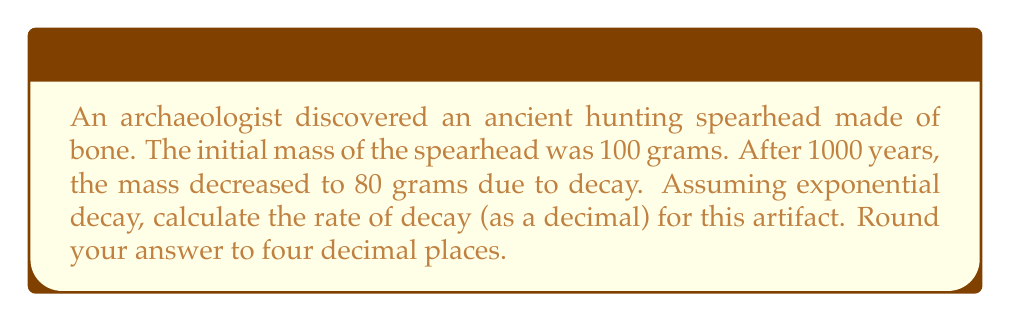Give your solution to this math problem. Let's approach this step-by-step using the exponential decay formula:

1) The exponential decay formula is:
   $A(t) = A_0 e^{-rt}$
   where:
   $A(t)$ is the amount at time $t$
   $A_0$ is the initial amount
   $r$ is the decay rate
   $t$ is the time

2) We know:
   $A_0 = 100$ grams (initial mass)
   $A(t) = 80$ grams (mass after 1000 years)
   $t = 1000$ years

3) Let's plug these into our formula:
   $80 = 100 e^{-r(1000)}$

4) Divide both sides by 100:
   $0.8 = e^{-1000r}$

5) Take the natural log of both sides:
   $\ln(0.8) = -1000r$

6) Solve for $r$:
   $r = -\frac{\ln(0.8)}{1000}$

7) Calculate:
   $r = -\frac{-0.223143551}{1000} = 0.000223143551$

8) Round to four decimal places:
   $r \approx 0.0002$
Answer: $0.0002$ 